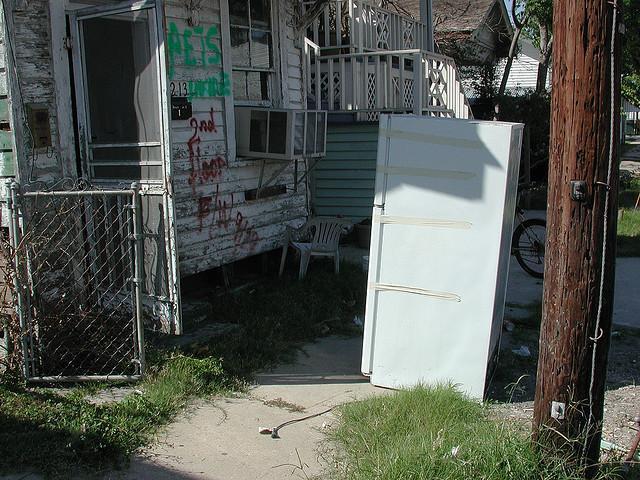How many green bottles are there?
Give a very brief answer. 0. 